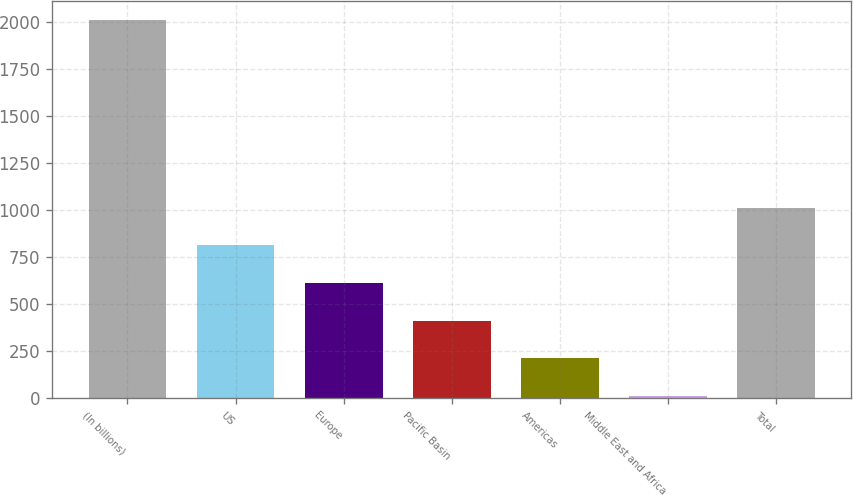Convert chart. <chart><loc_0><loc_0><loc_500><loc_500><bar_chart><fcel>(In billions)<fcel>US<fcel>Europe<fcel>Pacific Basin<fcel>Americas<fcel>Middle East and Africa<fcel>Total<nl><fcel>2012<fcel>811.94<fcel>611.93<fcel>411.92<fcel>211.91<fcel>11.9<fcel>1011.95<nl></chart> 